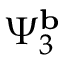Convert formula to latex. <formula><loc_0><loc_0><loc_500><loc_500>\Psi _ { 3 } ^ { b }</formula> 